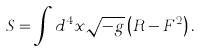<formula> <loc_0><loc_0><loc_500><loc_500>S = \int d ^ { 4 } x \sqrt { - g } \left ( R - F ^ { 2 } \right ) .</formula> 